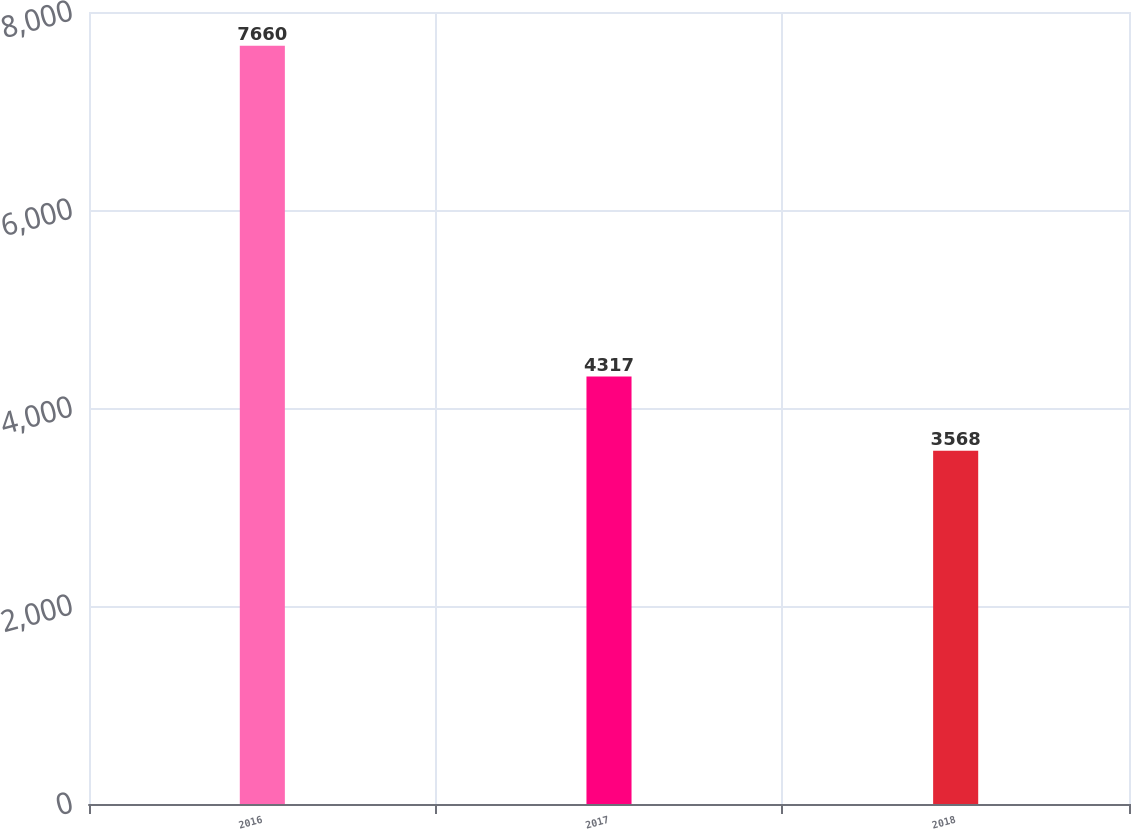<chart> <loc_0><loc_0><loc_500><loc_500><bar_chart><fcel>2016<fcel>2017<fcel>2018<nl><fcel>7660<fcel>4317<fcel>3568<nl></chart> 